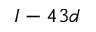Convert formula to latex. <formula><loc_0><loc_0><loc_500><loc_500>I - 4 3 d</formula> 